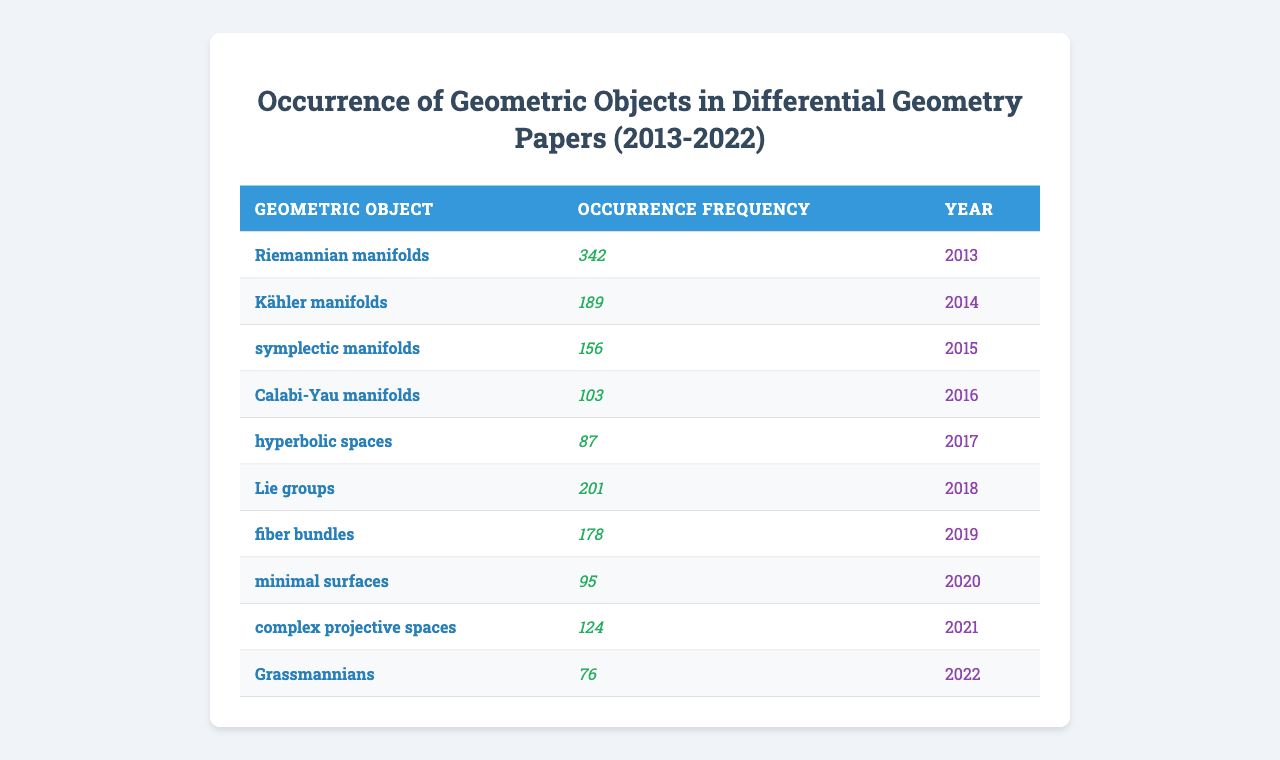What is the most frequent geometric object mentioned in the papers? The table shows the occurrence frequency for each geometric object. By checking the values, "Riemannian manifolds" has the highest frequency of 342.
Answer: Riemannian manifolds What is the occurrence frequency of Calabi-Yau manifolds? The table lists the occurrence frequency for Calabi-Yau manifolds as 103.
Answer: 103 Which geometric object has the lowest occurrence frequency? By inspecting the occurrence frequencies, "Grassmannians" has the lowest frequency recorded at 76.
Answer: Grassmannians What is the total occurrence frequency of all the geometric objects? The total frequency is the sum of all individual frequencies: 342 + 189 + 156 + 103 + 87 + 201 + 178 + 95 + 124 + 76 = 1871.
Answer: 1871 What is the average occurrence frequency of the geometric objects? The average can be calculated by dividing the total frequency (1871) by the number of geometric objects (10): 1871 / 10 = 187.1.
Answer: 187.1 Is the occurrence frequency of Kähler manifolds greater than that of minimal surfaces? Kähler manifolds has an occurrence frequency of 189, while minimal surfaces has a frequency of 95. Since 189 > 95, the statement is true.
Answer: Yes Which year had the highest occurrence frequency for geometric objects, and what was it? Inspecting the table reveals the highest single frequency of 342 corresponds to the year 2013.
Answer: 2013, 342 How many more occurrences of Lie groups are there than hyperbolic spaces? The frequency of Lie groups is 201 and hyperbolic spaces is 87. The difference is 201 - 87 = 114.
Answer: 114 What percentage of the total occurrences does the frequency of symplectic manifolds represent? Symplectic manifolds occurs 156 times, and the total is 1871. Thus, the percentage is (156 / 1871) * 100 = approximately 8.34%.
Answer: Approximately 8.34% If we rank the geometric objects by their occurrence frequency, which objects would be in the top three positions? The top three occurrences based on the values are "Riemannian manifolds" (342), "Lie groups" (201), and "Kähler manifolds" (189).
Answer: Riemannian manifolds, Lie groups, Kähler manifolds 